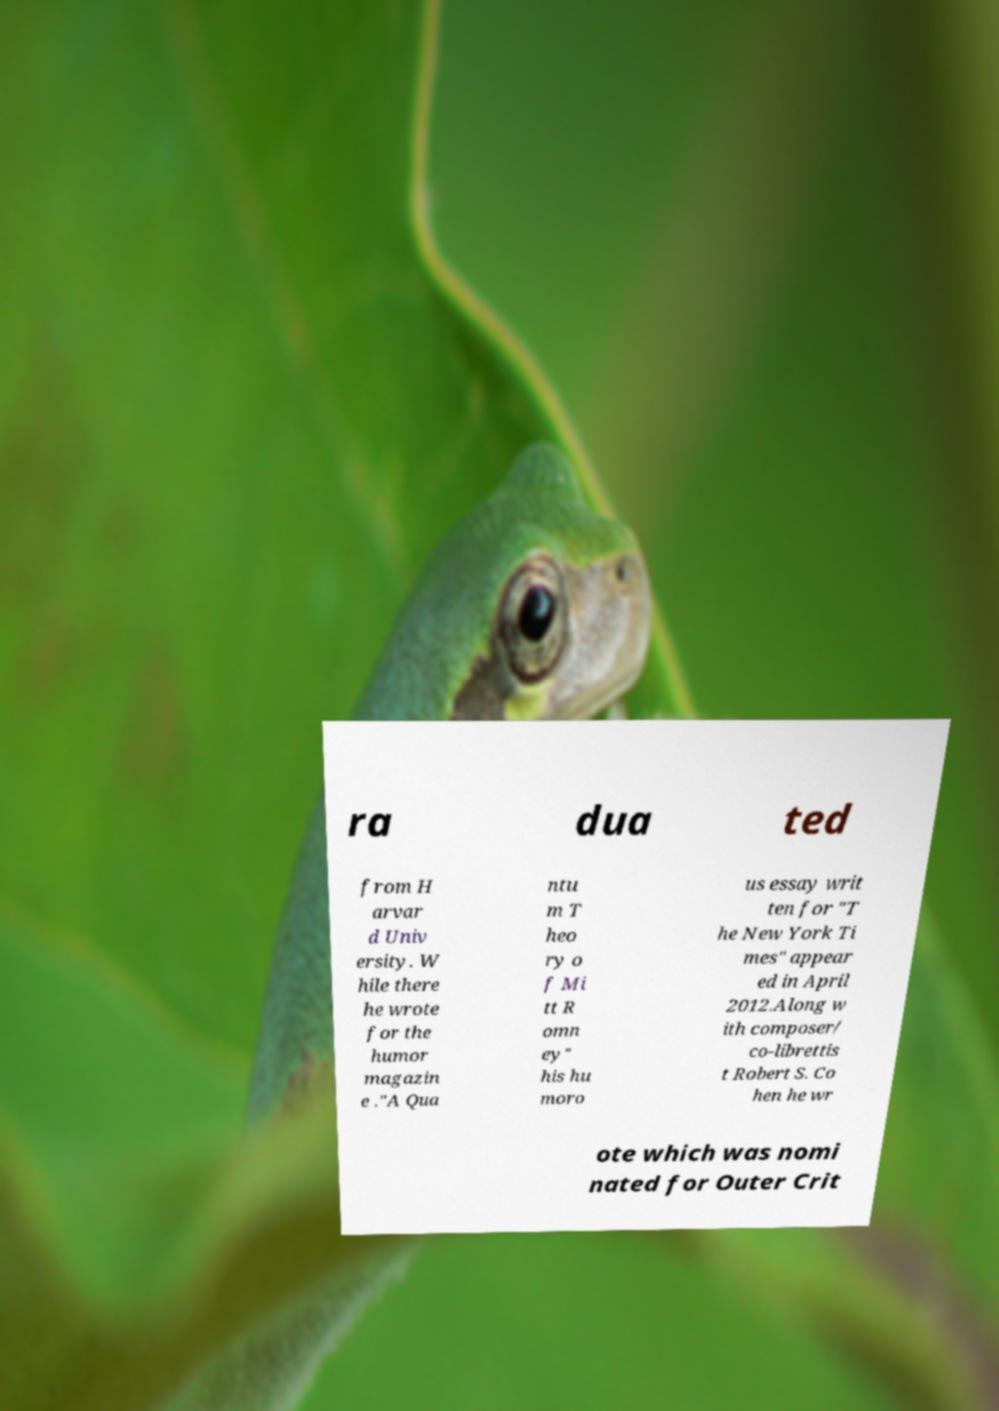There's text embedded in this image that I need extracted. Can you transcribe it verbatim? ra dua ted from H arvar d Univ ersity. W hile there he wrote for the humor magazin e ."A Qua ntu m T heo ry o f Mi tt R omn ey" his hu moro us essay writ ten for "T he New York Ti mes" appear ed in April 2012.Along w ith composer/ co-librettis t Robert S. Co hen he wr ote which was nomi nated for Outer Crit 